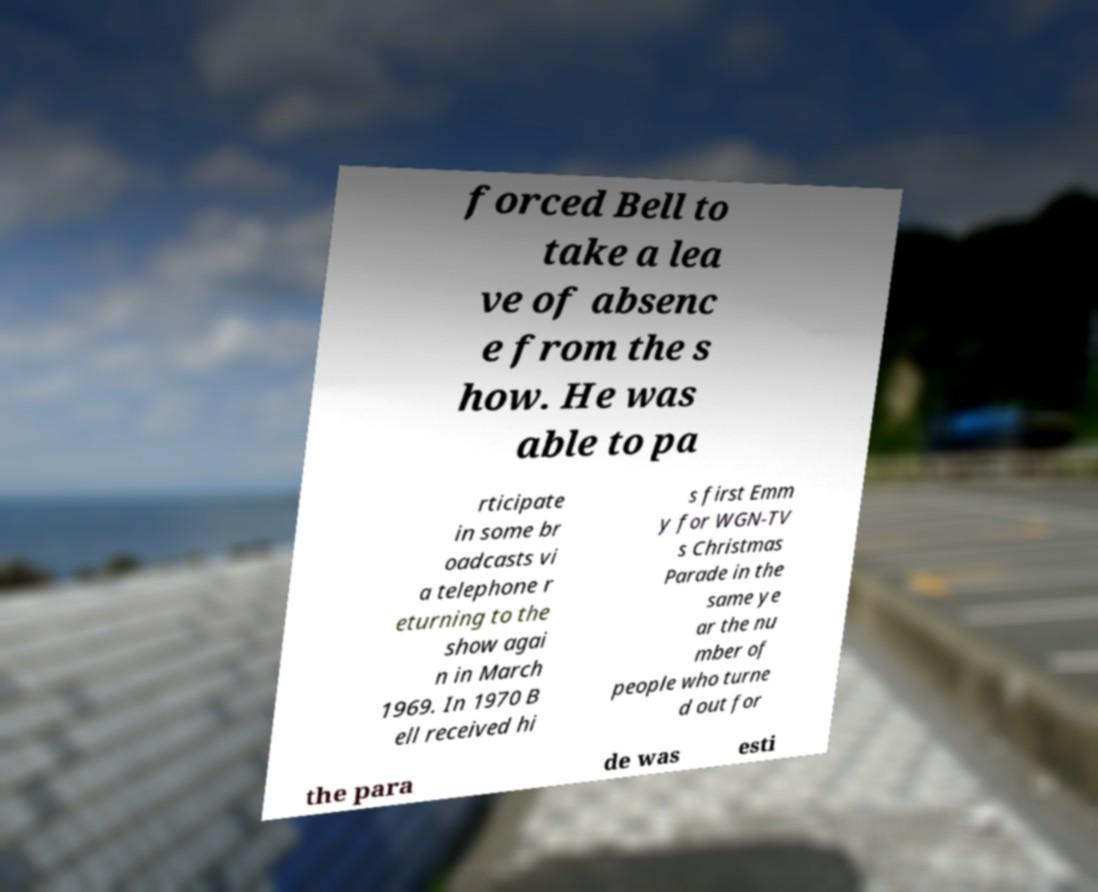Please read and relay the text visible in this image. What does it say? forced Bell to take a lea ve of absenc e from the s how. He was able to pa rticipate in some br oadcasts vi a telephone r eturning to the show agai n in March 1969. In 1970 B ell received hi s first Emm y for WGN-TV s Christmas Parade in the same ye ar the nu mber of people who turne d out for the para de was esti 